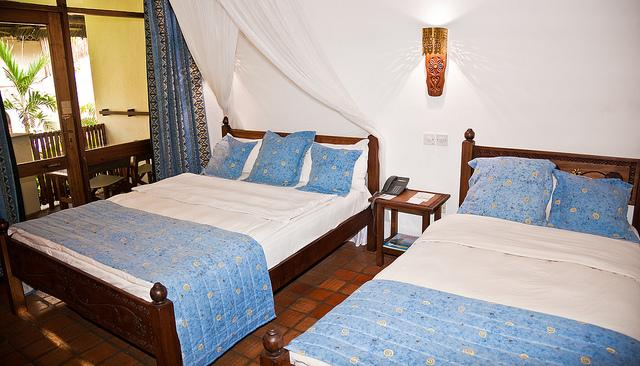What size are these beds? queen 